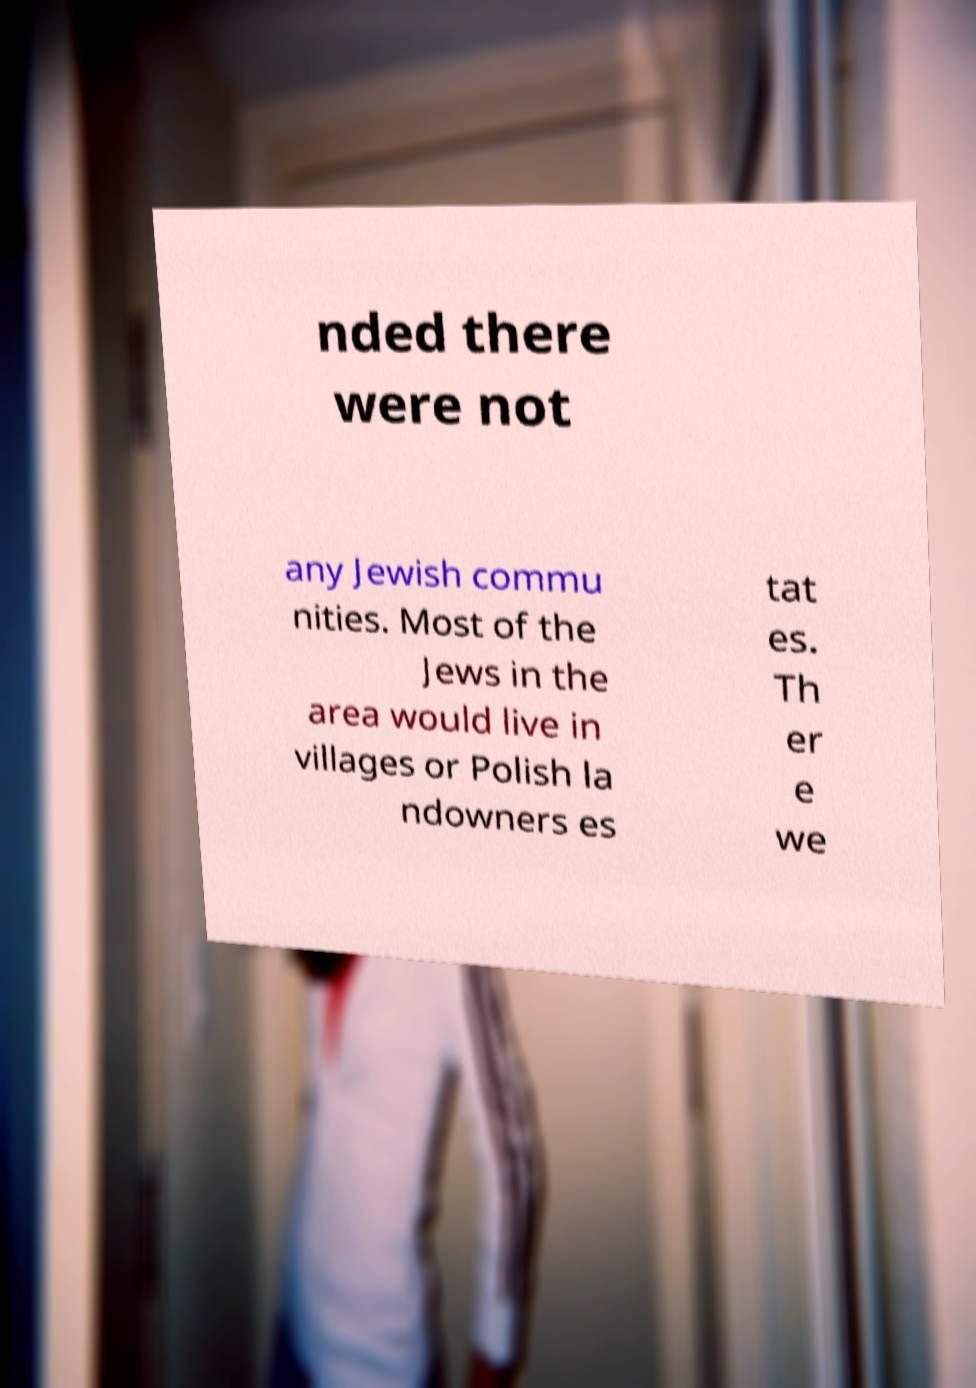Could you extract and type out the text from this image? nded there were not any Jewish commu nities. Most of the Jews in the area would live in villages or Polish la ndowners es tat es. Th er e we 